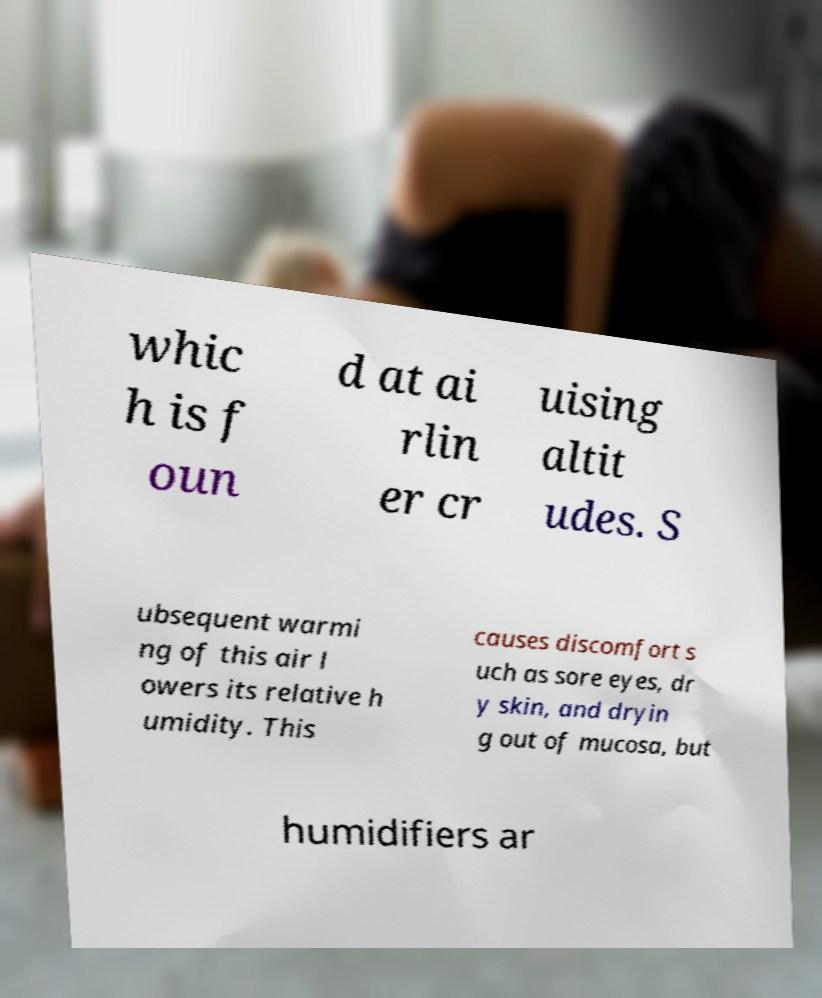Please read and relay the text visible in this image. What does it say? whic h is f oun d at ai rlin er cr uising altit udes. S ubsequent warmi ng of this air l owers its relative h umidity. This causes discomfort s uch as sore eyes, dr y skin, and dryin g out of mucosa, but humidifiers ar 